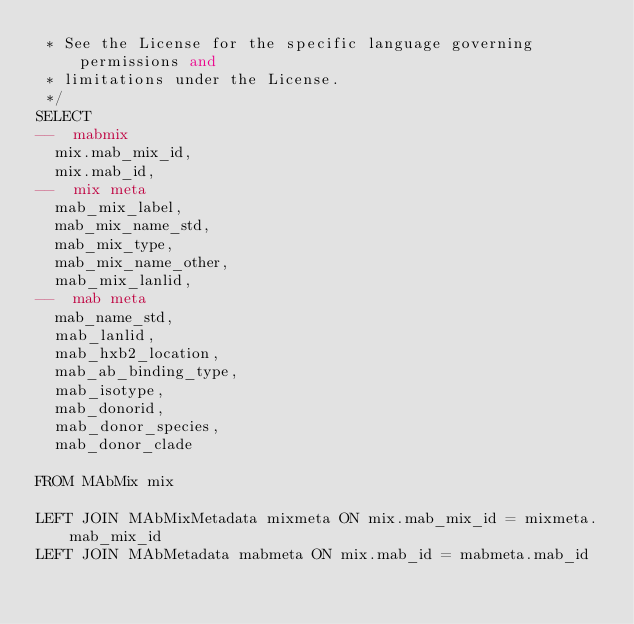<code> <loc_0><loc_0><loc_500><loc_500><_SQL_> * See the License for the specific language governing permissions and
 * limitations under the License.
 */
SELECT
--  mabmix
  mix.mab_mix_id,
  mix.mab_id,
--  mix meta
  mab_mix_label,
  mab_mix_name_std,
  mab_mix_type,
  mab_mix_name_other,
  mab_mix_lanlid,
--  mab meta
  mab_name_std,
  mab_lanlid,
  mab_hxb2_location,
  mab_ab_binding_type,
  mab_isotype,
  mab_donorid,
  mab_donor_species,
  mab_donor_clade

FROM MAbMix mix

LEFT JOIN MAbMixMetadata mixmeta ON mix.mab_mix_id = mixmeta.mab_mix_id
LEFT JOIN MAbMetadata mabmeta ON mix.mab_id = mabmeta.mab_id</code> 